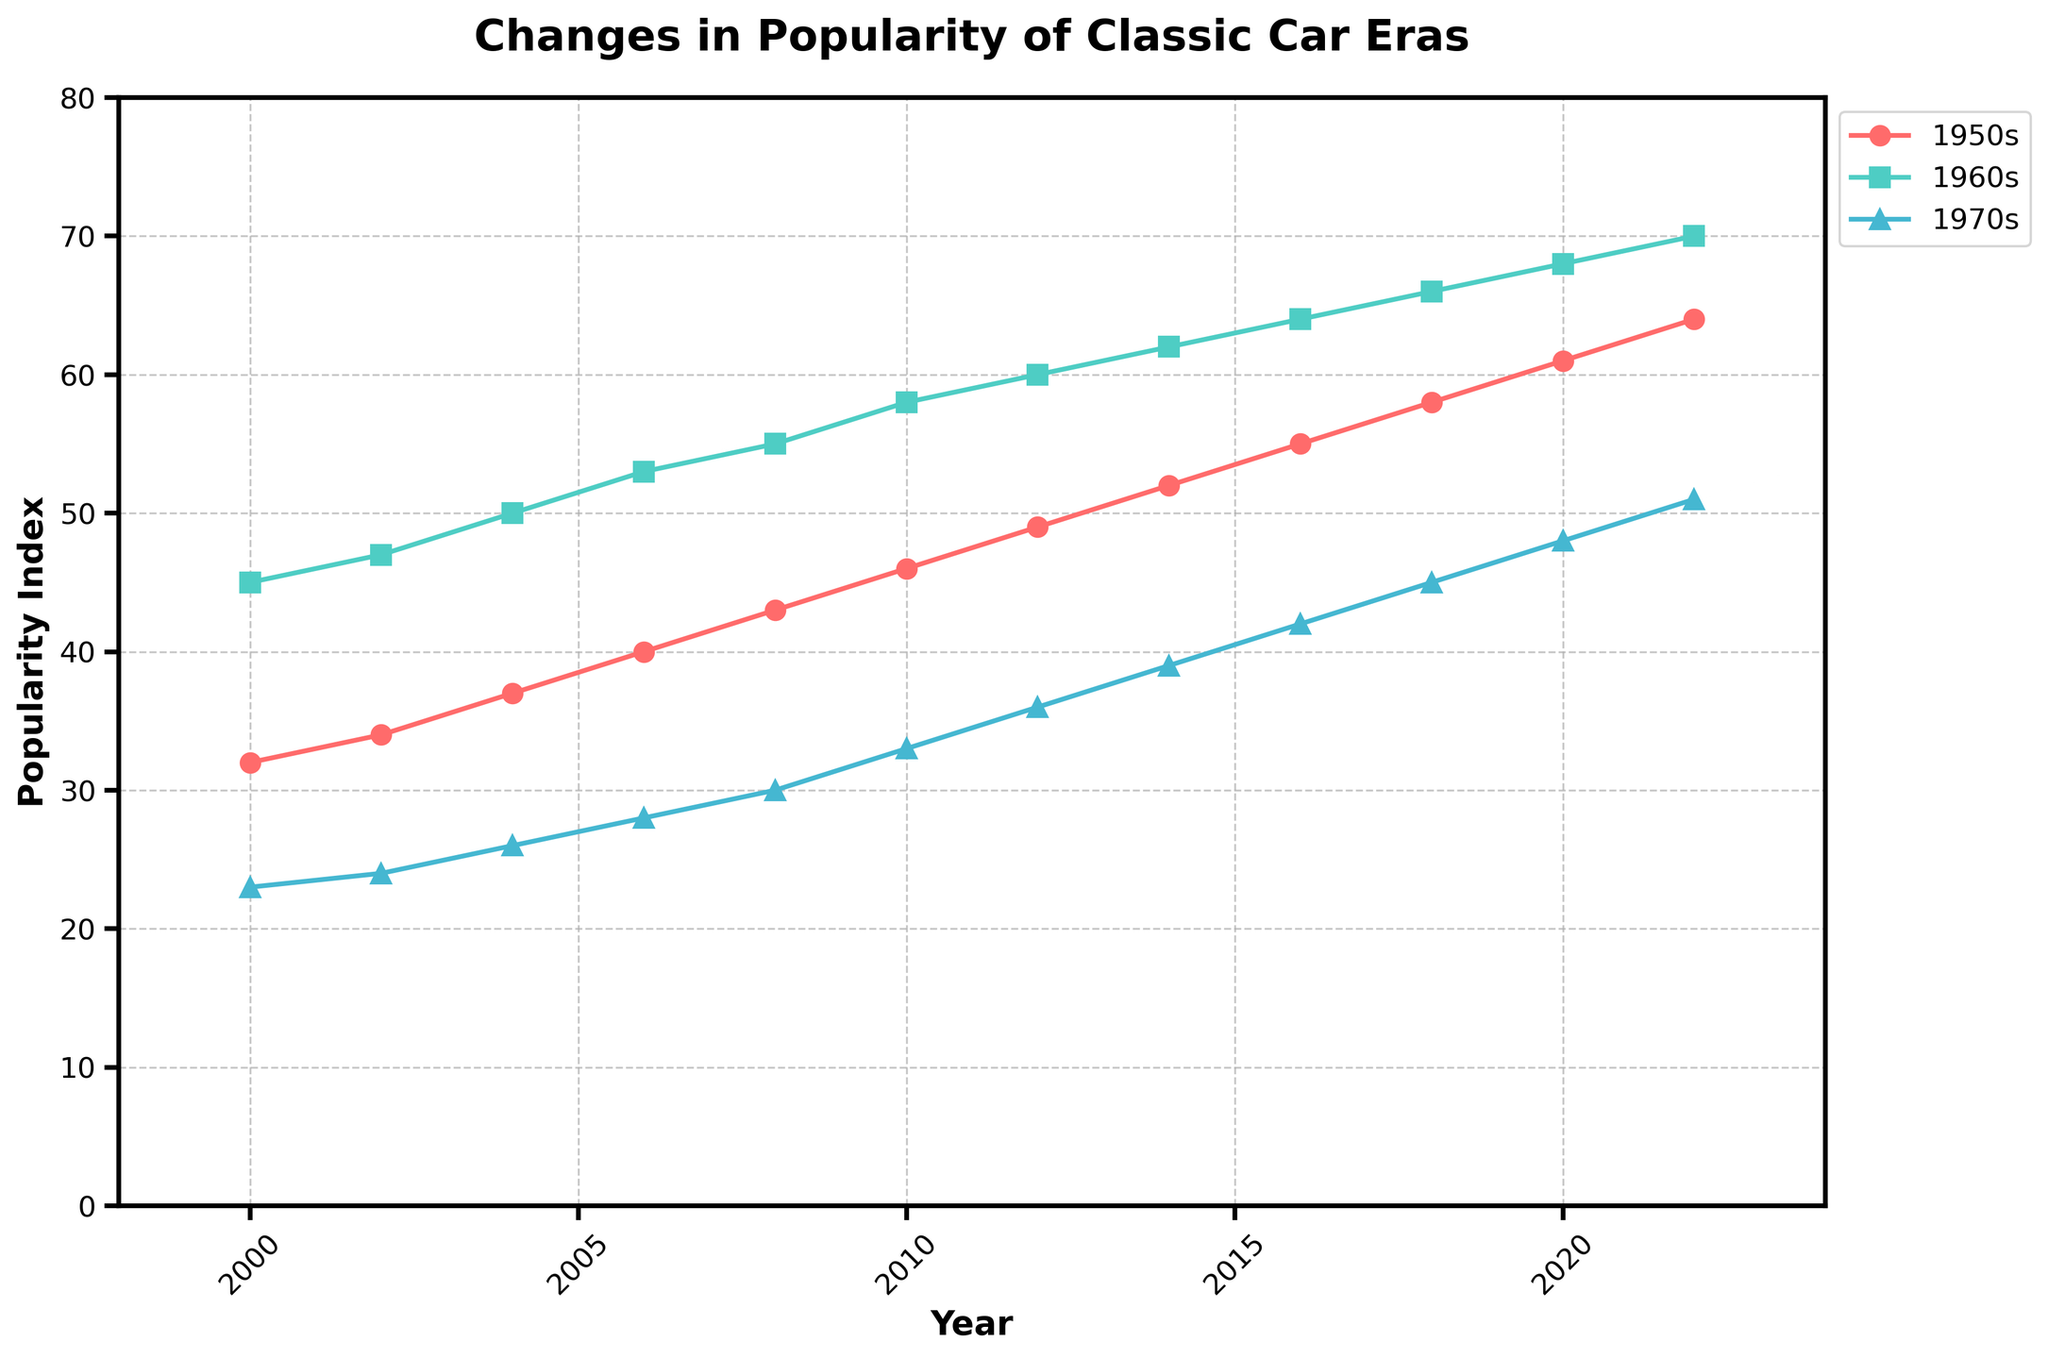What is the overall trend for the popularity of 1950s cars from 2000 to 2022? The plot shows an upward trend for the 1950s cars. Popularity index increased steadily from 32 in 2000 to 64 in 2022.
Answer: Increasing Between which years did the 1960s cars see the most significant increase in popularity? To find this, look for the steepest slope for the 1960s line. The most notable increase is from 2018 (66) to 2022 (70), where it increased by 4.
Answer: 2018 to 2022 How does the popularity index of 1970s cars in 2006 compare to that of 1950s cars in 2002? The index for 1970s cars in 2006 is 28, while for 1950s cars in 2002, it’s 34. Thus, the 1950s cars have a higher popularity index by 6 points in those years.
Answer: 1950s higher by 6 Which era has the highest popularity index in 2022? The plot shows that in 2022, the 1960s cars peaked highest at 70, compared to 64 for 1950s cars and 51 for 1970s cars.
Answer: 1960s Which year did cars from the 1950s reach a popularity index of 50? By checking the plot, we see that the 1950s cars reached a popularity index of 50 in 2004.
Answer: 2004 How much did the popularity of 1960s cars increase from 2000 to 2010? The index for 1960s in 2000 was 45, and it was 58 in 2010. Thus, the increase is 58 - 45 = 13.
Answer: 13 Comparing the popularity index of 1970s cars in 2010 and 1960s cars in 2008, which is higher and by how much? In 2010, the index for 1970s cars is 33, and for 1960s cars in 2008, it’s 55. The 1960s cars are higher by 22.
Answer: 1960s by 22 What is the average popularity index of 1970s cars from 2000 to 2022? Summing up the indices [23, 24, 26, 28, 30, 33, 36, 39, 42, 45, 48, 51] and dividing by 12. So, the average is (23 + 24 + 26 + 28 + 30 + 33 + 36 + 39 + 42 + 45 + 48 + 51) / 12 = 344 / 12 ≈ 28.67
Answer: 28.67 Did cars from the 1960s ever have a lower popularity index than the cars from the 1950s? If yes, in which year(s)? From the plot, 1960s cars were always more popular than 1950s cars throughout the years depicted, from 2000 to 2022.
Answer: No What can you infer about the trend in popularity of 1970s cars over the 22-year period provided? The plot shows a consistent upward trend. The popularity index for 1970s cars increased from 23 in 2000 to 51 in 2022, indicating a steady rise in interest.
Answer: Increasing 